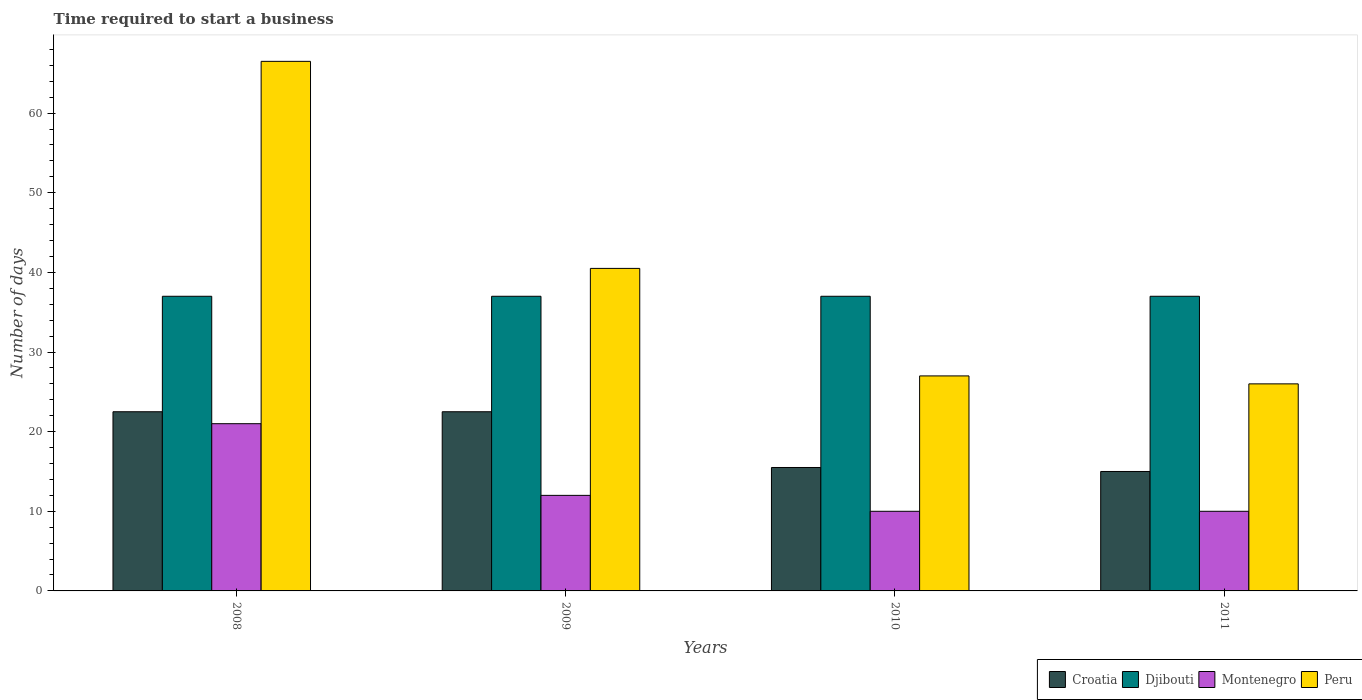How many groups of bars are there?
Provide a succinct answer. 4. Are the number of bars per tick equal to the number of legend labels?
Your answer should be very brief. Yes. How many bars are there on the 3rd tick from the left?
Make the answer very short. 4. What is the label of the 3rd group of bars from the left?
Your response must be concise. 2010. What is the number of days required to start a business in Peru in 2008?
Your answer should be very brief. 66.5. Across all years, what is the minimum number of days required to start a business in Montenegro?
Keep it short and to the point. 10. What is the total number of days required to start a business in Montenegro in the graph?
Provide a succinct answer. 53. What is the difference between the number of days required to start a business in Peru in 2011 and the number of days required to start a business in Djibouti in 2010?
Give a very brief answer. -11. In how many years, is the number of days required to start a business in Peru greater than 44 days?
Provide a short and direct response. 1. What is the ratio of the number of days required to start a business in Djibouti in 2009 to that in 2011?
Your answer should be very brief. 1. Is the number of days required to start a business in Montenegro in 2008 less than that in 2009?
Ensure brevity in your answer.  No. Is the difference between the number of days required to start a business in Croatia in 2009 and 2010 greater than the difference between the number of days required to start a business in Peru in 2009 and 2010?
Your answer should be compact. No. What is the difference between the highest and the second highest number of days required to start a business in Croatia?
Provide a short and direct response. 0. What does the 2nd bar from the left in 2008 represents?
Provide a short and direct response. Djibouti. What does the 3rd bar from the right in 2010 represents?
Offer a very short reply. Djibouti. How many bars are there?
Ensure brevity in your answer.  16. Are the values on the major ticks of Y-axis written in scientific E-notation?
Offer a terse response. No. Does the graph contain any zero values?
Your answer should be compact. No. Does the graph contain grids?
Offer a terse response. No. What is the title of the graph?
Offer a terse response. Time required to start a business. What is the label or title of the Y-axis?
Give a very brief answer. Number of days. What is the Number of days in Peru in 2008?
Offer a very short reply. 66.5. What is the Number of days in Croatia in 2009?
Ensure brevity in your answer.  22.5. What is the Number of days of Djibouti in 2009?
Provide a short and direct response. 37. What is the Number of days in Peru in 2009?
Provide a succinct answer. 40.5. What is the Number of days in Djibouti in 2010?
Offer a terse response. 37. What is the Number of days of Peru in 2010?
Offer a very short reply. 27. What is the Number of days in Croatia in 2011?
Your answer should be very brief. 15. What is the Number of days of Montenegro in 2011?
Make the answer very short. 10. Across all years, what is the maximum Number of days in Djibouti?
Provide a short and direct response. 37. Across all years, what is the maximum Number of days of Peru?
Offer a very short reply. 66.5. Across all years, what is the minimum Number of days in Croatia?
Ensure brevity in your answer.  15. Across all years, what is the minimum Number of days in Djibouti?
Your response must be concise. 37. What is the total Number of days in Croatia in the graph?
Your response must be concise. 75.5. What is the total Number of days in Djibouti in the graph?
Offer a very short reply. 148. What is the total Number of days in Peru in the graph?
Your answer should be very brief. 160. What is the difference between the Number of days in Croatia in 2008 and that in 2009?
Make the answer very short. 0. What is the difference between the Number of days in Montenegro in 2008 and that in 2009?
Give a very brief answer. 9. What is the difference between the Number of days of Peru in 2008 and that in 2010?
Provide a succinct answer. 39.5. What is the difference between the Number of days in Croatia in 2008 and that in 2011?
Ensure brevity in your answer.  7.5. What is the difference between the Number of days of Montenegro in 2008 and that in 2011?
Give a very brief answer. 11. What is the difference between the Number of days in Peru in 2008 and that in 2011?
Ensure brevity in your answer.  40.5. What is the difference between the Number of days of Montenegro in 2009 and that in 2010?
Your answer should be compact. 2. What is the difference between the Number of days of Peru in 2009 and that in 2010?
Offer a very short reply. 13.5. What is the difference between the Number of days of Croatia in 2009 and that in 2011?
Offer a terse response. 7.5. What is the difference between the Number of days of Djibouti in 2009 and that in 2011?
Offer a very short reply. 0. What is the difference between the Number of days in Peru in 2009 and that in 2011?
Make the answer very short. 14.5. What is the difference between the Number of days in Croatia in 2010 and that in 2011?
Provide a succinct answer. 0.5. What is the difference between the Number of days in Croatia in 2008 and the Number of days in Djibouti in 2009?
Make the answer very short. -14.5. What is the difference between the Number of days in Croatia in 2008 and the Number of days in Montenegro in 2009?
Give a very brief answer. 10.5. What is the difference between the Number of days in Croatia in 2008 and the Number of days in Peru in 2009?
Your answer should be compact. -18. What is the difference between the Number of days in Djibouti in 2008 and the Number of days in Montenegro in 2009?
Give a very brief answer. 25. What is the difference between the Number of days in Montenegro in 2008 and the Number of days in Peru in 2009?
Your answer should be compact. -19.5. What is the difference between the Number of days in Djibouti in 2008 and the Number of days in Peru in 2010?
Provide a short and direct response. 10. What is the difference between the Number of days in Montenegro in 2008 and the Number of days in Peru in 2010?
Offer a very short reply. -6. What is the difference between the Number of days of Croatia in 2008 and the Number of days of Djibouti in 2011?
Offer a very short reply. -14.5. What is the difference between the Number of days of Croatia in 2008 and the Number of days of Peru in 2011?
Your answer should be compact. -3.5. What is the difference between the Number of days of Djibouti in 2008 and the Number of days of Peru in 2011?
Offer a terse response. 11. What is the difference between the Number of days in Croatia in 2009 and the Number of days in Djibouti in 2010?
Keep it short and to the point. -14.5. What is the difference between the Number of days of Croatia in 2009 and the Number of days of Montenegro in 2010?
Provide a succinct answer. 12.5. What is the difference between the Number of days in Djibouti in 2009 and the Number of days in Peru in 2010?
Ensure brevity in your answer.  10. What is the difference between the Number of days in Montenegro in 2009 and the Number of days in Peru in 2010?
Give a very brief answer. -15. What is the difference between the Number of days of Croatia in 2009 and the Number of days of Montenegro in 2011?
Your answer should be very brief. 12.5. What is the difference between the Number of days of Djibouti in 2009 and the Number of days of Montenegro in 2011?
Your answer should be very brief. 27. What is the difference between the Number of days in Djibouti in 2009 and the Number of days in Peru in 2011?
Offer a very short reply. 11. What is the difference between the Number of days of Croatia in 2010 and the Number of days of Djibouti in 2011?
Your response must be concise. -21.5. What is the difference between the Number of days of Djibouti in 2010 and the Number of days of Montenegro in 2011?
Give a very brief answer. 27. What is the difference between the Number of days of Djibouti in 2010 and the Number of days of Peru in 2011?
Give a very brief answer. 11. What is the average Number of days in Croatia per year?
Provide a short and direct response. 18.88. What is the average Number of days of Djibouti per year?
Provide a short and direct response. 37. What is the average Number of days in Montenegro per year?
Provide a short and direct response. 13.25. In the year 2008, what is the difference between the Number of days in Croatia and Number of days in Montenegro?
Give a very brief answer. 1.5. In the year 2008, what is the difference between the Number of days in Croatia and Number of days in Peru?
Your answer should be compact. -44. In the year 2008, what is the difference between the Number of days of Djibouti and Number of days of Peru?
Keep it short and to the point. -29.5. In the year 2008, what is the difference between the Number of days in Montenegro and Number of days in Peru?
Your answer should be very brief. -45.5. In the year 2009, what is the difference between the Number of days of Djibouti and Number of days of Montenegro?
Provide a short and direct response. 25. In the year 2009, what is the difference between the Number of days in Montenegro and Number of days in Peru?
Provide a succinct answer. -28.5. In the year 2010, what is the difference between the Number of days of Croatia and Number of days of Djibouti?
Provide a succinct answer. -21.5. In the year 2010, what is the difference between the Number of days of Croatia and Number of days of Peru?
Provide a succinct answer. -11.5. In the year 2011, what is the difference between the Number of days of Djibouti and Number of days of Peru?
Offer a very short reply. 11. What is the ratio of the Number of days in Croatia in 2008 to that in 2009?
Make the answer very short. 1. What is the ratio of the Number of days in Djibouti in 2008 to that in 2009?
Your response must be concise. 1. What is the ratio of the Number of days in Peru in 2008 to that in 2009?
Give a very brief answer. 1.64. What is the ratio of the Number of days in Croatia in 2008 to that in 2010?
Provide a short and direct response. 1.45. What is the ratio of the Number of days in Djibouti in 2008 to that in 2010?
Offer a terse response. 1. What is the ratio of the Number of days of Peru in 2008 to that in 2010?
Your answer should be very brief. 2.46. What is the ratio of the Number of days of Croatia in 2008 to that in 2011?
Keep it short and to the point. 1.5. What is the ratio of the Number of days in Peru in 2008 to that in 2011?
Provide a succinct answer. 2.56. What is the ratio of the Number of days in Croatia in 2009 to that in 2010?
Provide a short and direct response. 1.45. What is the ratio of the Number of days in Djibouti in 2009 to that in 2010?
Offer a very short reply. 1. What is the ratio of the Number of days in Croatia in 2009 to that in 2011?
Give a very brief answer. 1.5. What is the ratio of the Number of days of Djibouti in 2009 to that in 2011?
Ensure brevity in your answer.  1. What is the ratio of the Number of days of Peru in 2009 to that in 2011?
Offer a very short reply. 1.56. What is the ratio of the Number of days of Montenegro in 2010 to that in 2011?
Provide a short and direct response. 1. What is the ratio of the Number of days of Peru in 2010 to that in 2011?
Offer a very short reply. 1.04. What is the difference between the highest and the second highest Number of days in Montenegro?
Your answer should be compact. 9. What is the difference between the highest and the lowest Number of days of Djibouti?
Offer a very short reply. 0. What is the difference between the highest and the lowest Number of days of Peru?
Provide a short and direct response. 40.5. 